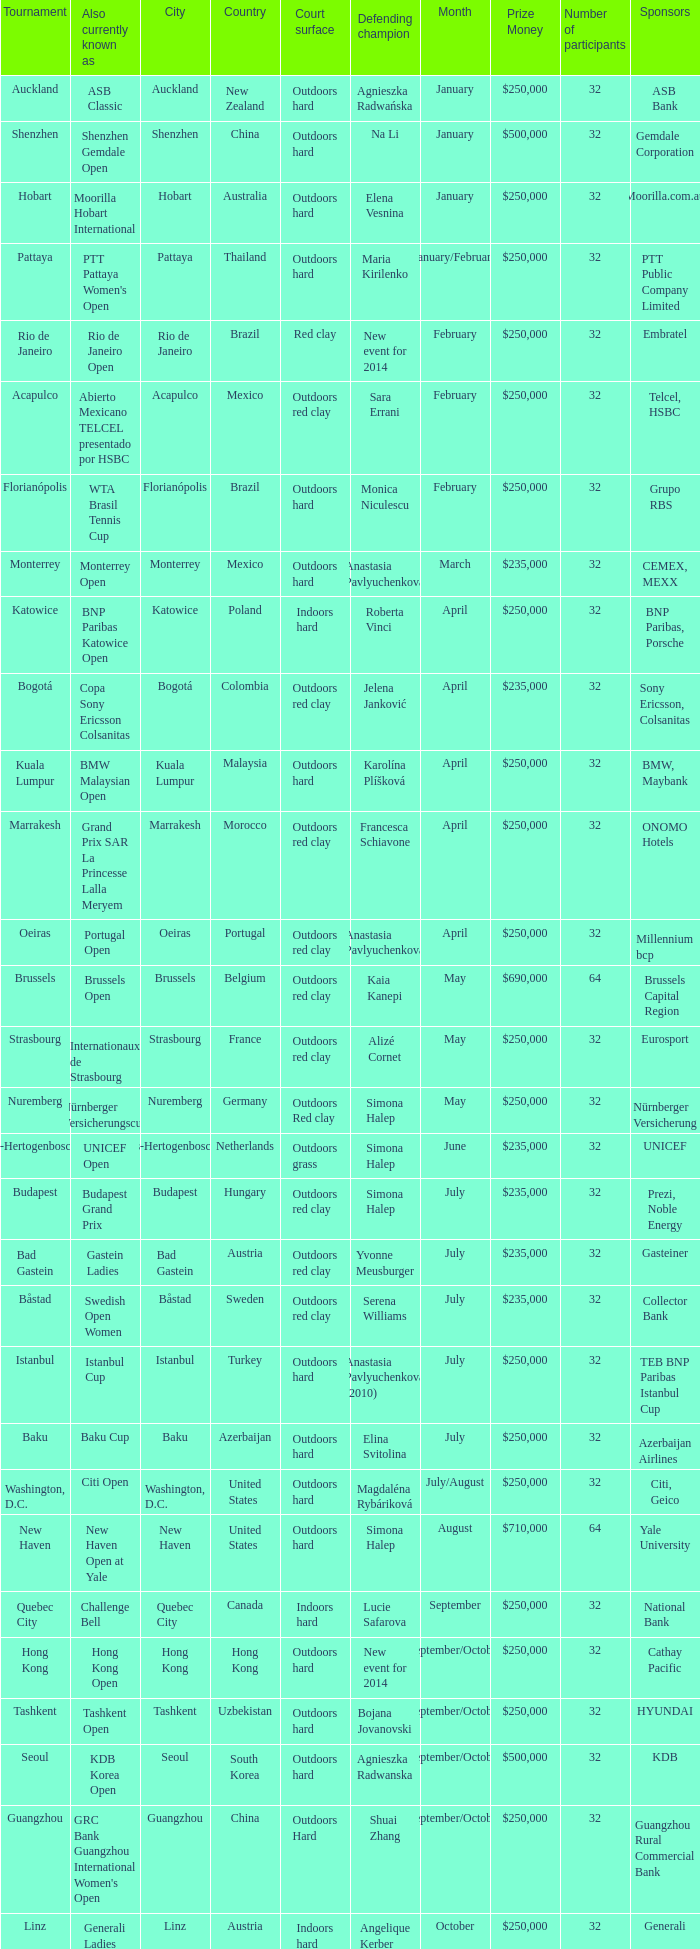How many defending champs from thailand? 1.0. 